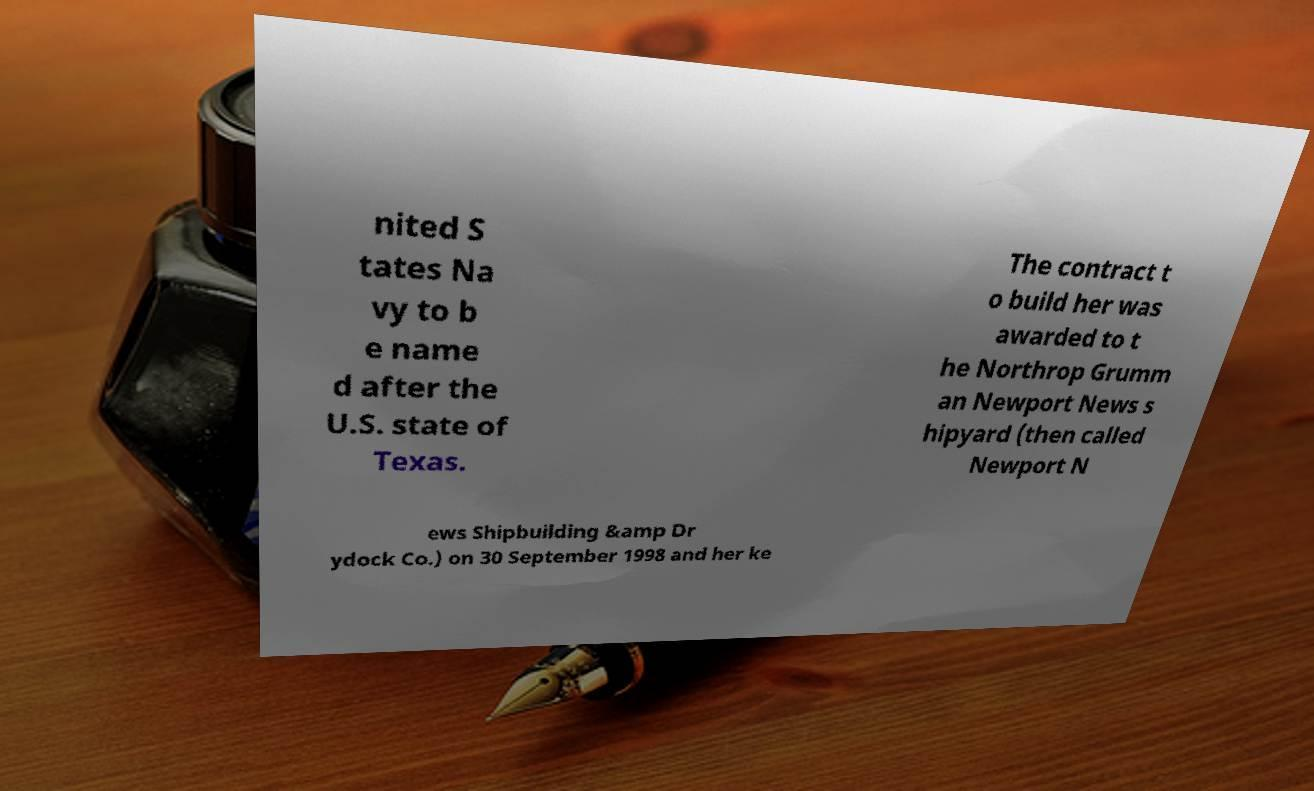There's text embedded in this image that I need extracted. Can you transcribe it verbatim? nited S tates Na vy to b e name d after the U.S. state of Texas. The contract t o build her was awarded to t he Northrop Grumm an Newport News s hipyard (then called Newport N ews Shipbuilding &amp Dr ydock Co.) on 30 September 1998 and her ke 